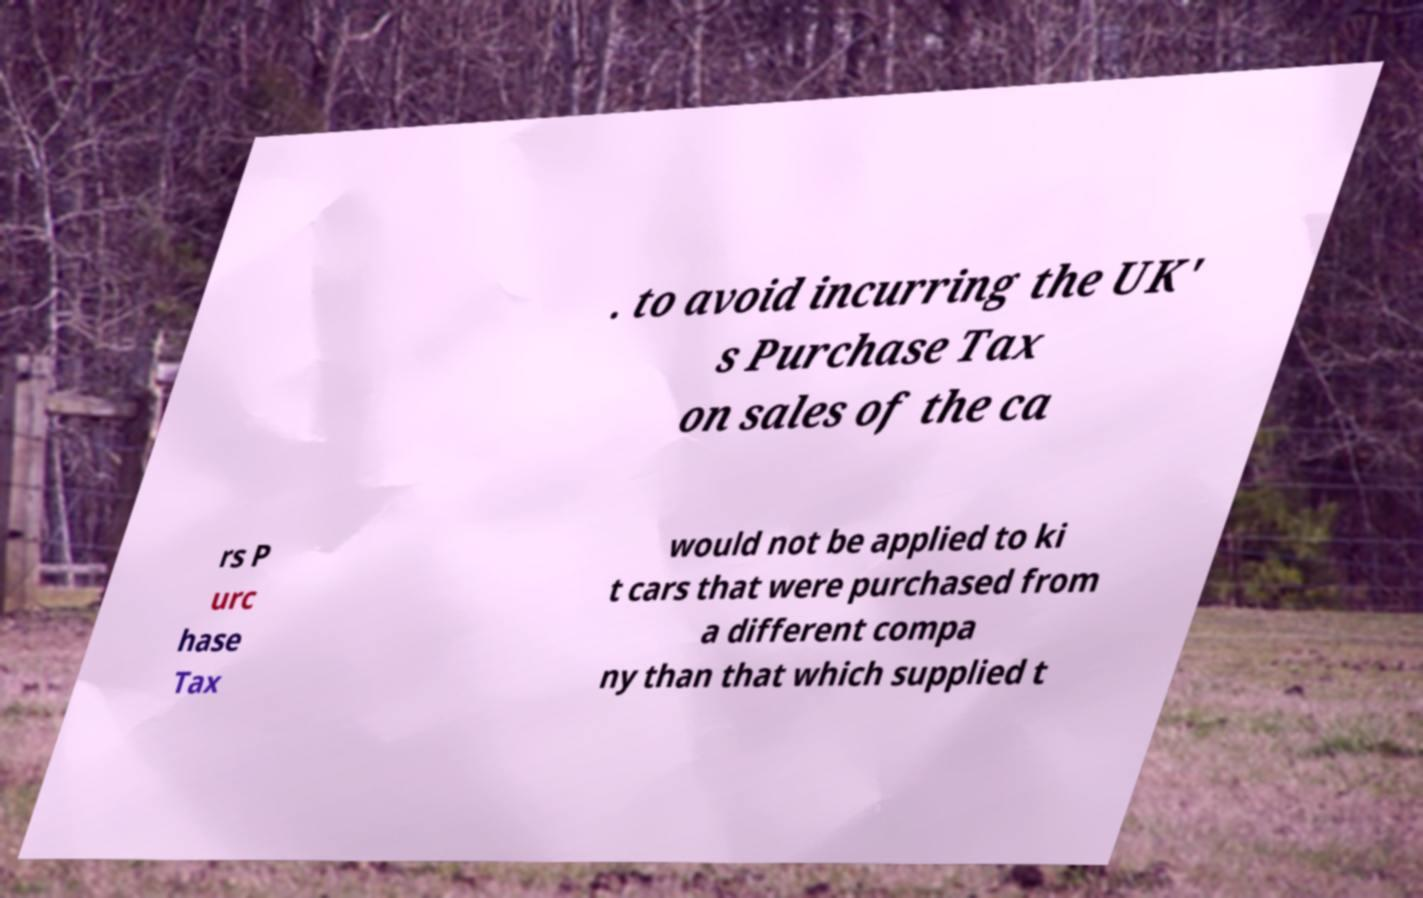For documentation purposes, I need the text within this image transcribed. Could you provide that? . to avoid incurring the UK' s Purchase Tax on sales of the ca rs P urc hase Tax would not be applied to ki t cars that were purchased from a different compa ny than that which supplied t 